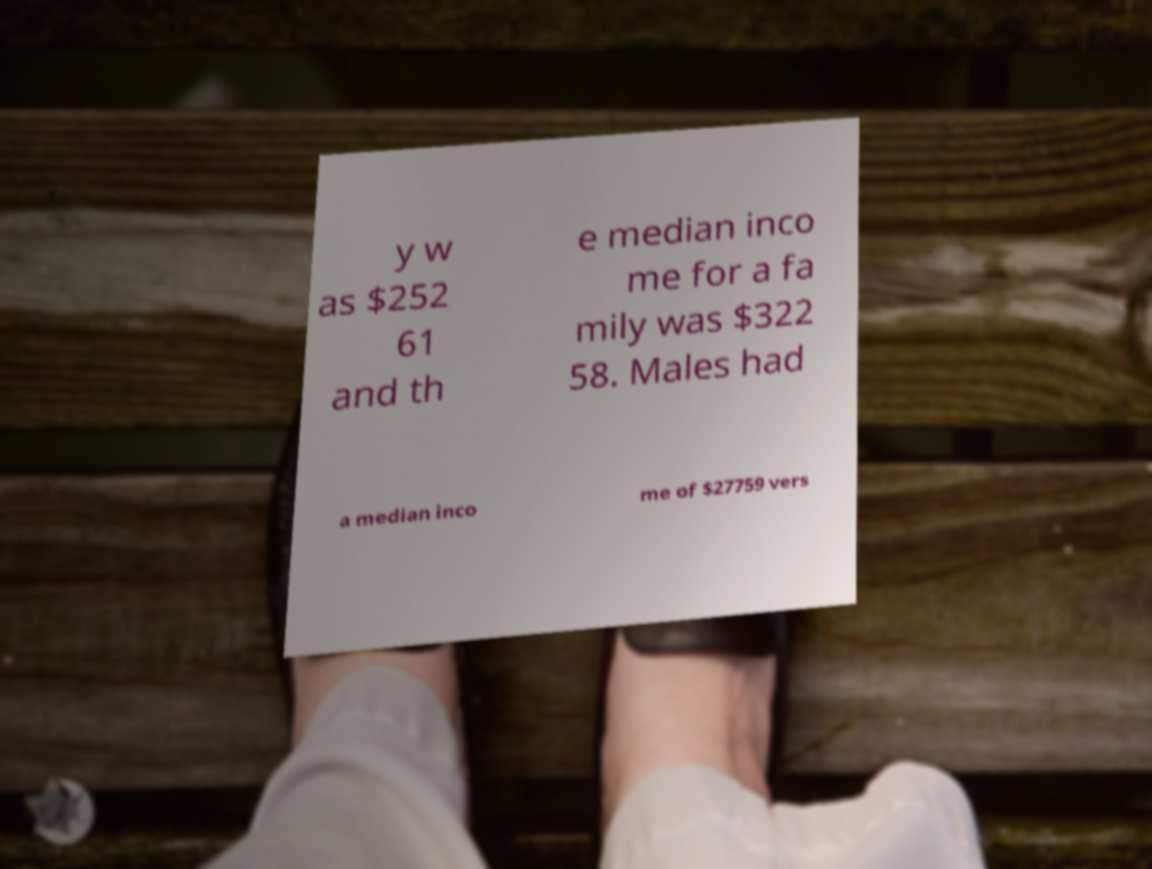Can you accurately transcribe the text from the provided image for me? y w as $252 61 and th e median inco me for a fa mily was $322 58. Males had a median inco me of $27759 vers 